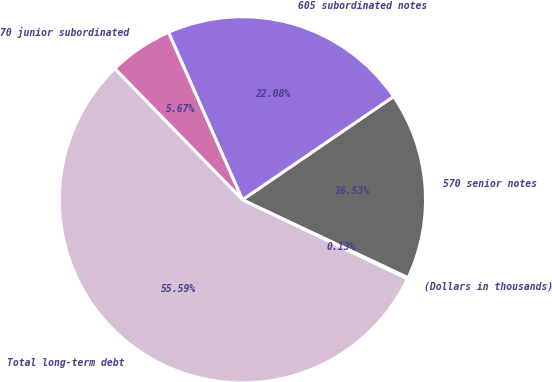<chart> <loc_0><loc_0><loc_500><loc_500><pie_chart><fcel>(Dollars in thousands)<fcel>570 senior notes<fcel>605 subordinated notes<fcel>70 junior subordinated<fcel>Total long-term debt<nl><fcel>0.13%<fcel>16.53%<fcel>22.08%<fcel>5.67%<fcel>55.59%<nl></chart> 